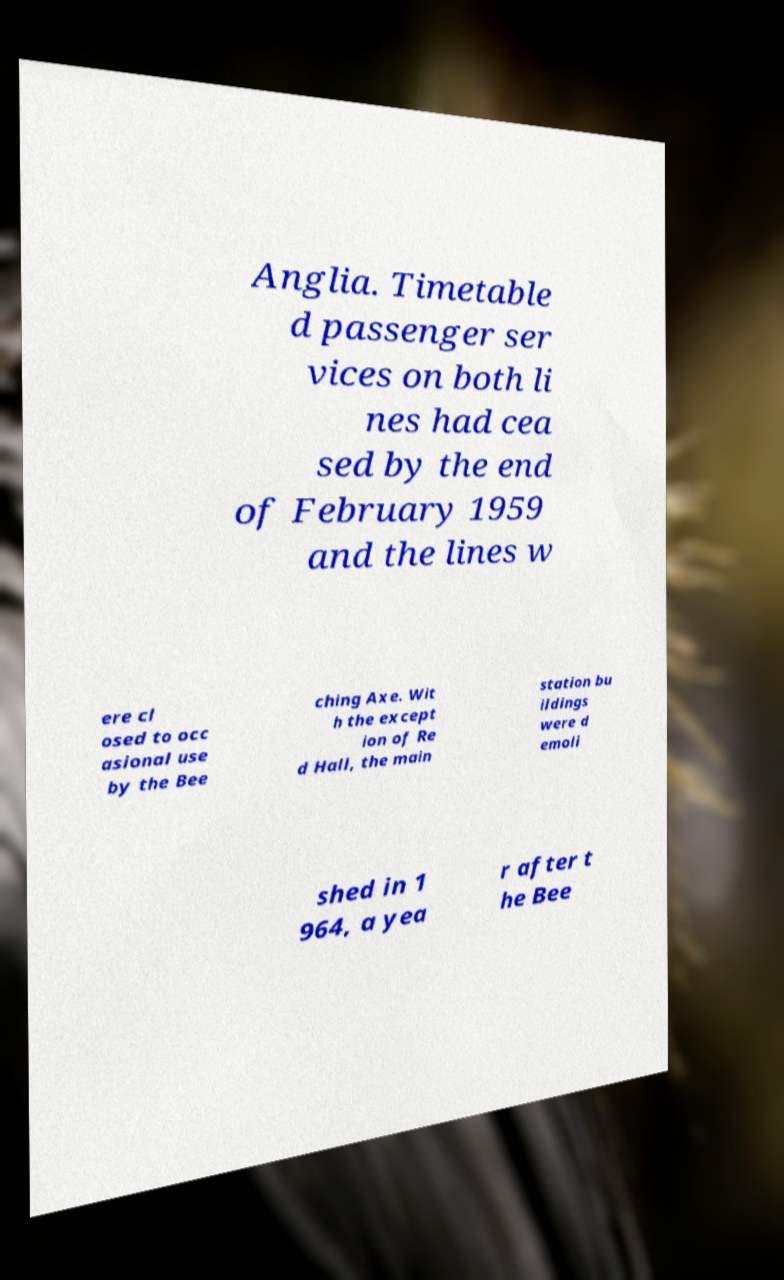There's text embedded in this image that I need extracted. Can you transcribe it verbatim? Anglia. Timetable d passenger ser vices on both li nes had cea sed by the end of February 1959 and the lines w ere cl osed to occ asional use by the Bee ching Axe. Wit h the except ion of Re d Hall, the main station bu ildings were d emoli shed in 1 964, a yea r after t he Bee 